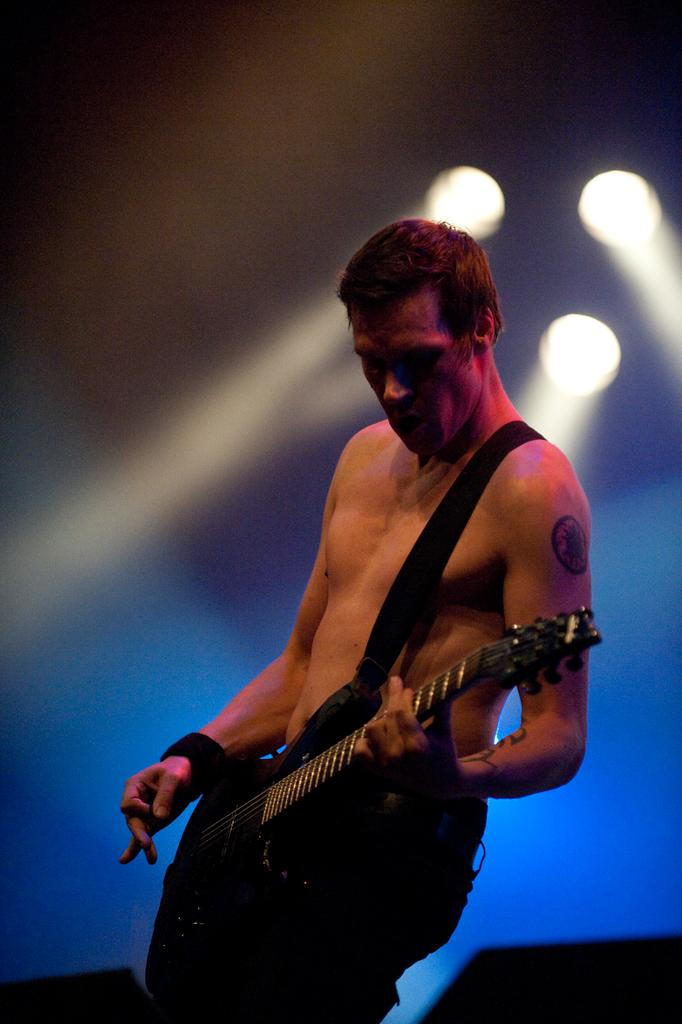What can be seen in the background of the image? There are lights in the background of the image. What is the man in the image doing? The man is playing a guitar. Can you describe any accessories the man is wearing? The man is wearing a wrist band on his hand. How many friends can be seen in the image? There is no mention of friends in the image, as it only features a man playing a guitar. What type of pin is the man wearing on his shirt in the image? There is no pin visible on the man's shirt in the image. 